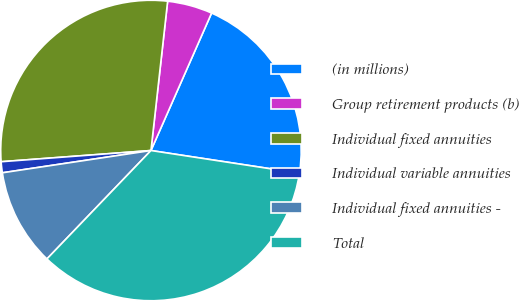Convert chart. <chart><loc_0><loc_0><loc_500><loc_500><pie_chart><fcel>(in millions)<fcel>Group retirement products (b)<fcel>Individual fixed annuities<fcel>Individual variable annuities<fcel>Individual fixed annuities -<fcel>Total<nl><fcel>20.8%<fcel>4.84%<fcel>27.96%<fcel>1.18%<fcel>10.46%<fcel>34.76%<nl></chart> 